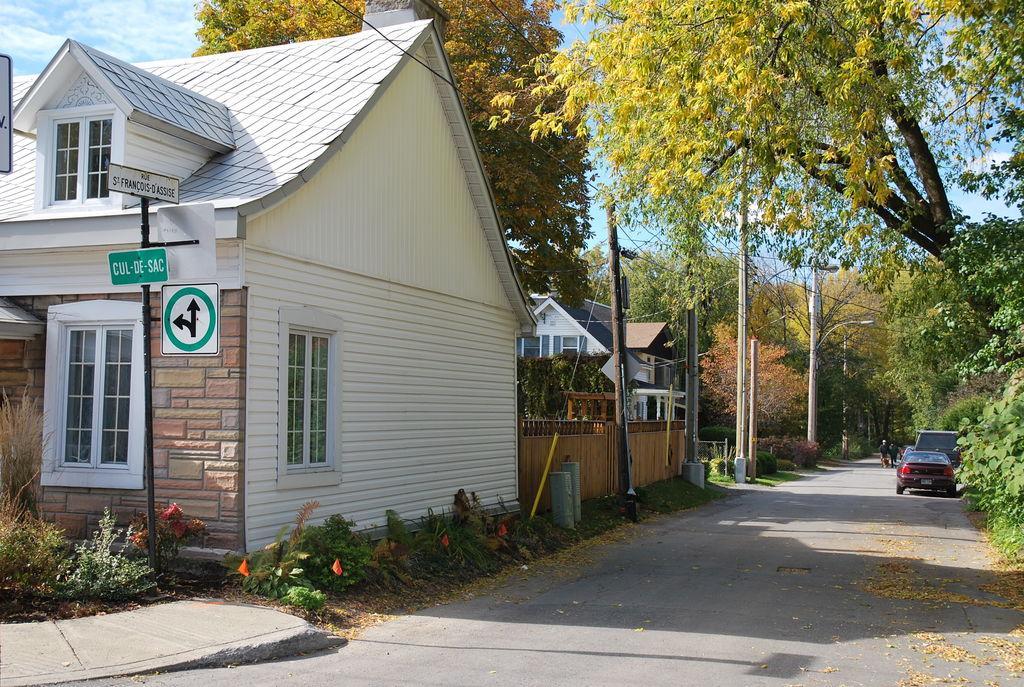Describe this image in one or two sentences. In the middle of the image there are some plants and poles and sign boards and buildings. On the right side of the image there are some vehicles on the road. Behind the vehicles two persons are walking. Behind them there are some trees. At the top of the image there are some clouds and sky. 